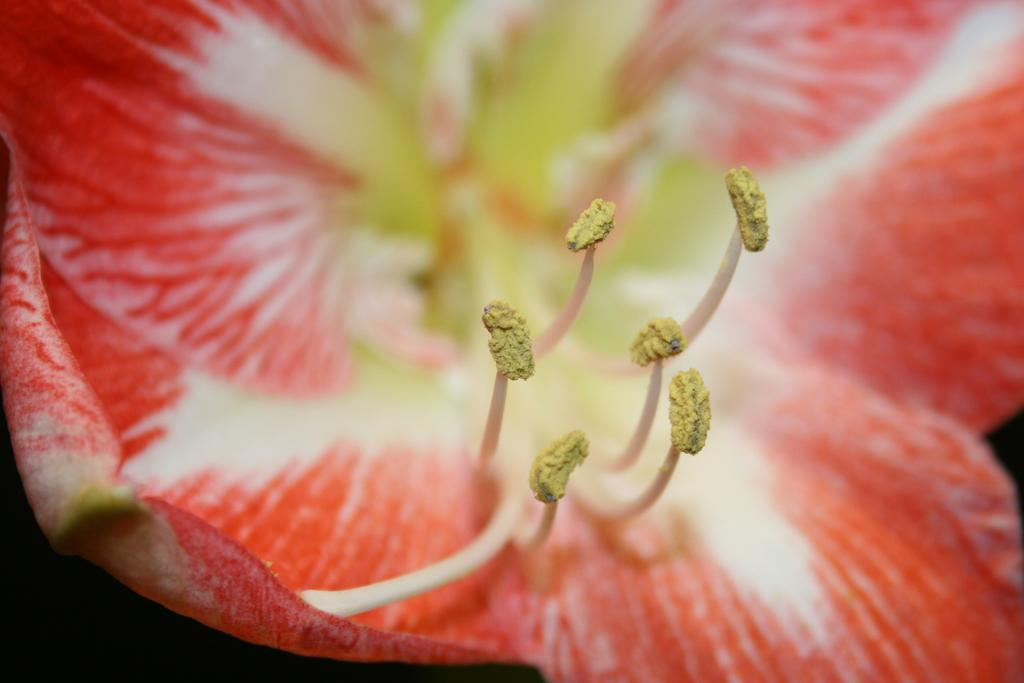What type of plant is in the image? There is a flower in the image. What color is the flower? The flower is red. What else can be seen on the plant in the image? There are buds in the image. What color are the buds? The buds are yellow. What type of society does the flower belong to in the image? The image does not depict a society, and the flower is not a member of any society. 